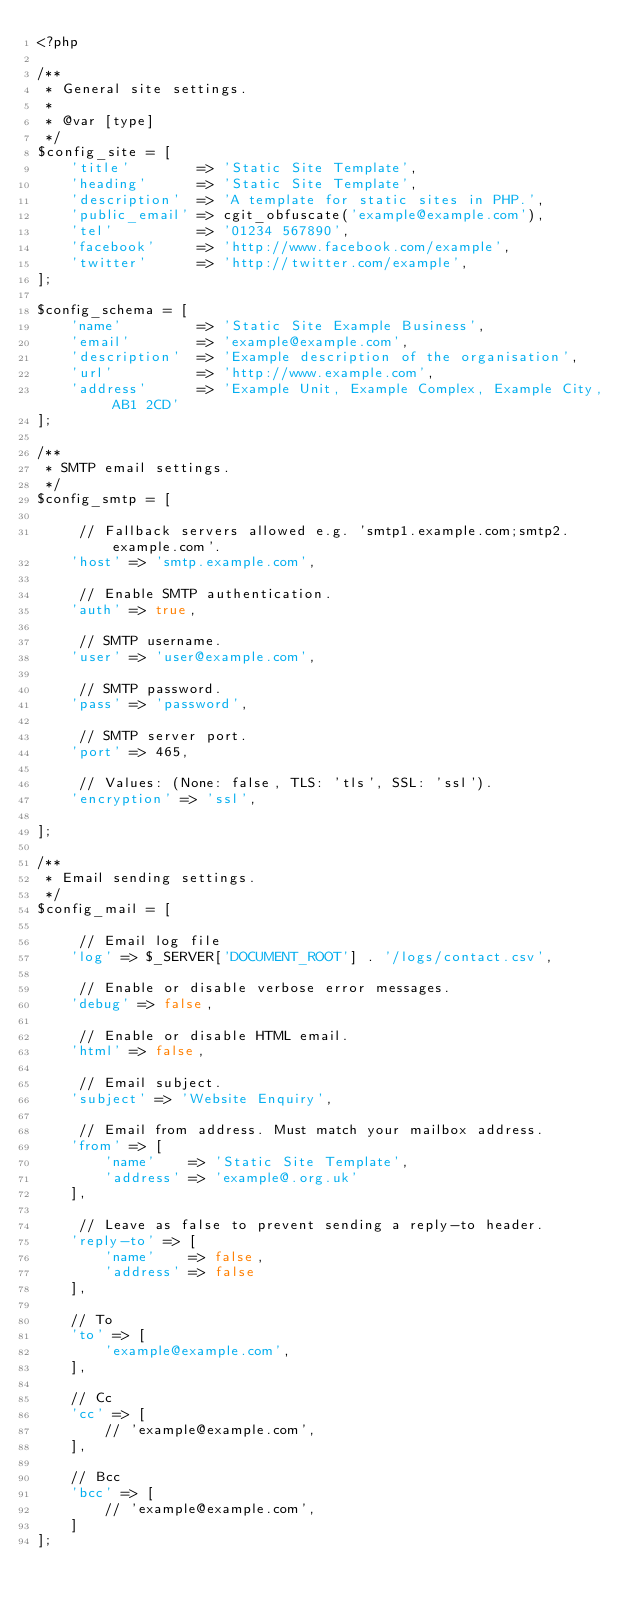<code> <loc_0><loc_0><loc_500><loc_500><_PHP_><?php

/**
 * General site settings.
 *
 * @var [type]
 */
$config_site = [
    'title'        => 'Static Site Template',
    'heading'      => 'Static Site Template',
    'description'  => 'A template for static sites in PHP.',
    'public_email' => cgit_obfuscate('example@example.com'),
    'tel'          => '01234 567890',
    'facebook'     => 'http://www.facebook.com/example',
    'twitter'      => 'http://twitter.com/example',
];

$config_schema = [
    'name'         => 'Static Site Example Business',
    'email'        => 'example@example.com',
    'description'  => 'Example description of the organisation',
    'url'          => 'http://www.example.com',
    'address'      => 'Example Unit, Example Complex, Example City, AB1 2CD'
];

/**
 * SMTP email settings.
 */
$config_smtp = [

     // Fallback servers allowed e.g. 'smtp1.example.com;smtp2.example.com'.
    'host' => 'smtp.example.com',

     // Enable SMTP authentication.
    'auth' => true,

     // SMTP username.
    'user' => 'user@example.com',

     // SMTP password.
    'pass' => 'password',

     // SMTP server port.
    'port' => 465,

     // Values: (None: false, TLS: 'tls', SSL: 'ssl').
    'encryption' => 'ssl',

];

/**
 * Email sending settings.
 */
$config_mail = [

     // Email log file
    'log' => $_SERVER['DOCUMENT_ROOT'] . '/logs/contact.csv',

     // Enable or disable verbose error messages.
    'debug' => false,

     // Enable or disable HTML email.
    'html' => false,

     // Email subject.
    'subject' => 'Website Enquiry',

     // Email from address. Must match your mailbox address.
    'from' => [
        'name'    => 'Static Site Template',
        'address' => 'example@.org.uk'
    ],

     // Leave as false to prevent sending a reply-to header.
    'reply-to' => [
        'name'    => false,
        'address' => false
    ],

    // To
    'to' => [
        'example@example.com',
    ],

    // Cc
    'cc' => [
        // 'example@example.com',
    ],

    // Bcc
    'bcc' => [
        // 'example@example.com',
    ]
];
</code> 